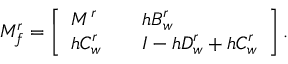<formula> <loc_0><loc_0><loc_500><loc_500>M _ { f } ^ { r } = \left [ \begin{array} { l l l } { M ^ { r } } & { h B _ { w } ^ { r } } \\ { h C _ { w } ^ { r } } & { I - h D _ { w } ^ { r } + h C _ { w } ^ { r } } \end{array} \right ] .</formula> 